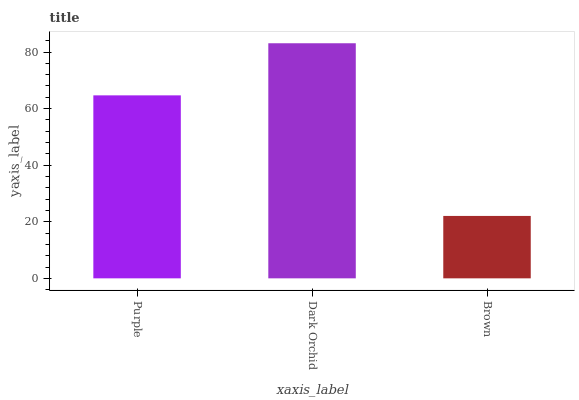Is Brown the minimum?
Answer yes or no. Yes. Is Dark Orchid the maximum?
Answer yes or no. Yes. Is Dark Orchid the minimum?
Answer yes or no. No. Is Brown the maximum?
Answer yes or no. No. Is Dark Orchid greater than Brown?
Answer yes or no. Yes. Is Brown less than Dark Orchid?
Answer yes or no. Yes. Is Brown greater than Dark Orchid?
Answer yes or no. No. Is Dark Orchid less than Brown?
Answer yes or no. No. Is Purple the high median?
Answer yes or no. Yes. Is Purple the low median?
Answer yes or no. Yes. Is Brown the high median?
Answer yes or no. No. Is Dark Orchid the low median?
Answer yes or no. No. 